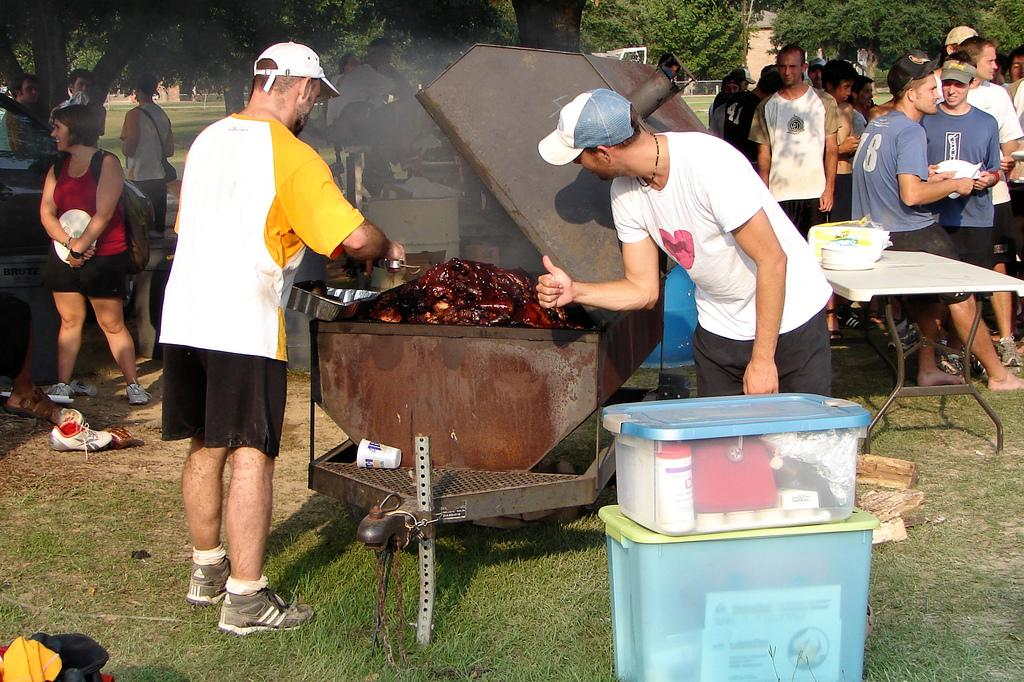<image>
Offer a succinct explanation of the picture presented. A group of people grilling, one man is wearing a shirt that reads 78 